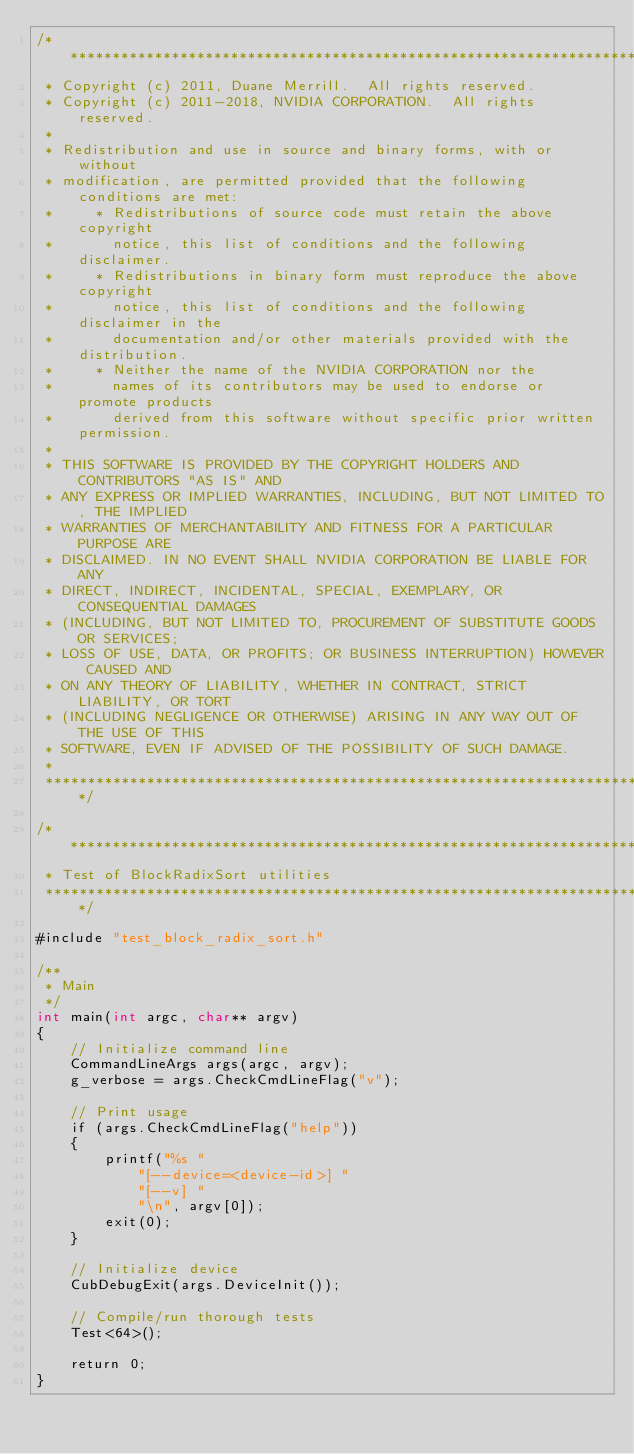<code> <loc_0><loc_0><loc_500><loc_500><_Cuda_>/******************************************************************************
 * Copyright (c) 2011, Duane Merrill.  All rights reserved.
 * Copyright (c) 2011-2018, NVIDIA CORPORATION.  All rights reserved.
 *
 * Redistribution and use in source and binary forms, with or without
 * modification, are permitted provided that the following conditions are met:
 *     * Redistributions of source code must retain the above copyright
 *       notice, this list of conditions and the following disclaimer.
 *     * Redistributions in binary form must reproduce the above copyright
 *       notice, this list of conditions and the following disclaimer in the
 *       documentation and/or other materials provided with the distribution.
 *     * Neither the name of the NVIDIA CORPORATION nor the
 *       names of its contributors may be used to endorse or promote products
 *       derived from this software without specific prior written permission.
 *
 * THIS SOFTWARE IS PROVIDED BY THE COPYRIGHT HOLDERS AND CONTRIBUTORS "AS IS" AND
 * ANY EXPRESS OR IMPLIED WARRANTIES, INCLUDING, BUT NOT LIMITED TO, THE IMPLIED
 * WARRANTIES OF MERCHANTABILITY AND FITNESS FOR A PARTICULAR PURPOSE ARE
 * DISCLAIMED. IN NO EVENT SHALL NVIDIA CORPORATION BE LIABLE FOR ANY
 * DIRECT, INDIRECT, INCIDENTAL, SPECIAL, EXEMPLARY, OR CONSEQUENTIAL DAMAGES
 * (INCLUDING, BUT NOT LIMITED TO, PROCUREMENT OF SUBSTITUTE GOODS OR SERVICES;
 * LOSS OF USE, DATA, OR PROFITS; OR BUSINESS INTERRUPTION) HOWEVER CAUSED AND
 * ON ANY THEORY OF LIABILITY, WHETHER IN CONTRACT, STRICT LIABILITY, OR TORT
 * (INCLUDING NEGLIGENCE OR OTHERWISE) ARISING IN ANY WAY OUT OF THE USE OF THIS
 * SOFTWARE, EVEN IF ADVISED OF THE POSSIBILITY OF SUCH DAMAGE.
 *
 ******************************************************************************/

/******************************************************************************
 * Test of BlockRadixSort utilities
 ******************************************************************************/

#include "test_block_radix_sort.h"

/**
 * Main
 */
int main(int argc, char** argv)
{
    // Initialize command line
    CommandLineArgs args(argc, argv);
    g_verbose = args.CheckCmdLineFlag("v");

    // Print usage
    if (args.CheckCmdLineFlag("help"))
    {
        printf("%s "
            "[--device=<device-id>] "
            "[--v] "
            "\n", argv[0]);
        exit(0);
    }

    // Initialize device
    CubDebugExit(args.DeviceInit());

    // Compile/run thorough tests
    Test<64>();

    return 0;
}
</code> 